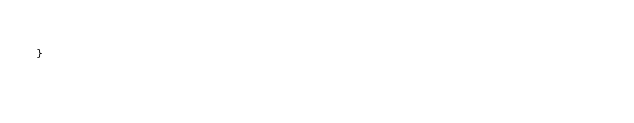<code> <loc_0><loc_0><loc_500><loc_500><_C_>
}
</code> 